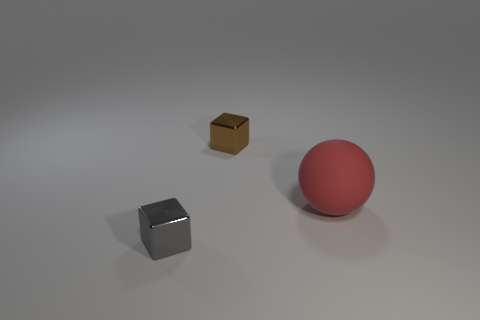Are there any other things that are made of the same material as the sphere?
Make the answer very short. No. There is a metal block to the right of the small gray object; what is its color?
Offer a terse response. Brown. There is a shiny thing behind the small gray shiny cube; is there a gray shiny object left of it?
Your answer should be compact. Yes. Are there fewer large blue rubber objects than rubber objects?
Provide a succinct answer. Yes. What is the object that is right of the cube that is behind the red rubber thing made of?
Provide a succinct answer. Rubber. Does the red rubber sphere have the same size as the gray shiny block?
Your response must be concise. No. What number of things are either large purple objects or gray shiny things?
Provide a succinct answer. 1. What is the size of the thing that is to the left of the red matte thing and in front of the brown shiny block?
Your response must be concise. Small. Are there fewer brown objects that are on the right side of the big red matte thing than big green blocks?
Your answer should be compact. No. The object that is made of the same material as the brown block is what shape?
Your answer should be compact. Cube. 